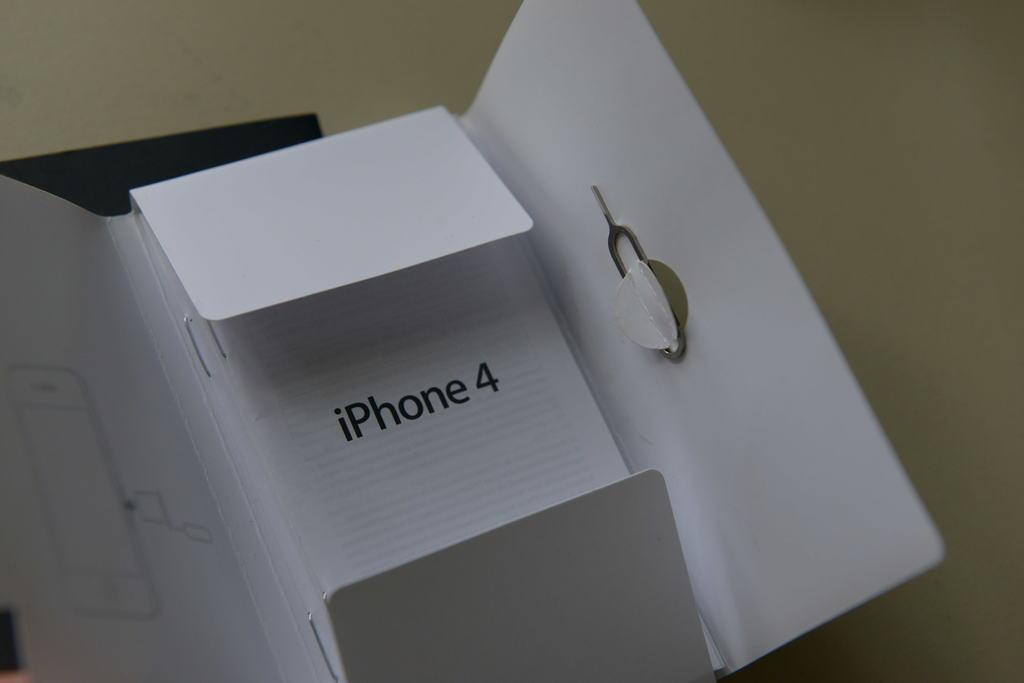What brand of phone came in this case?
Your answer should be compact. Iphone. Which version of the iphone is this?
Offer a very short reply. 4. 